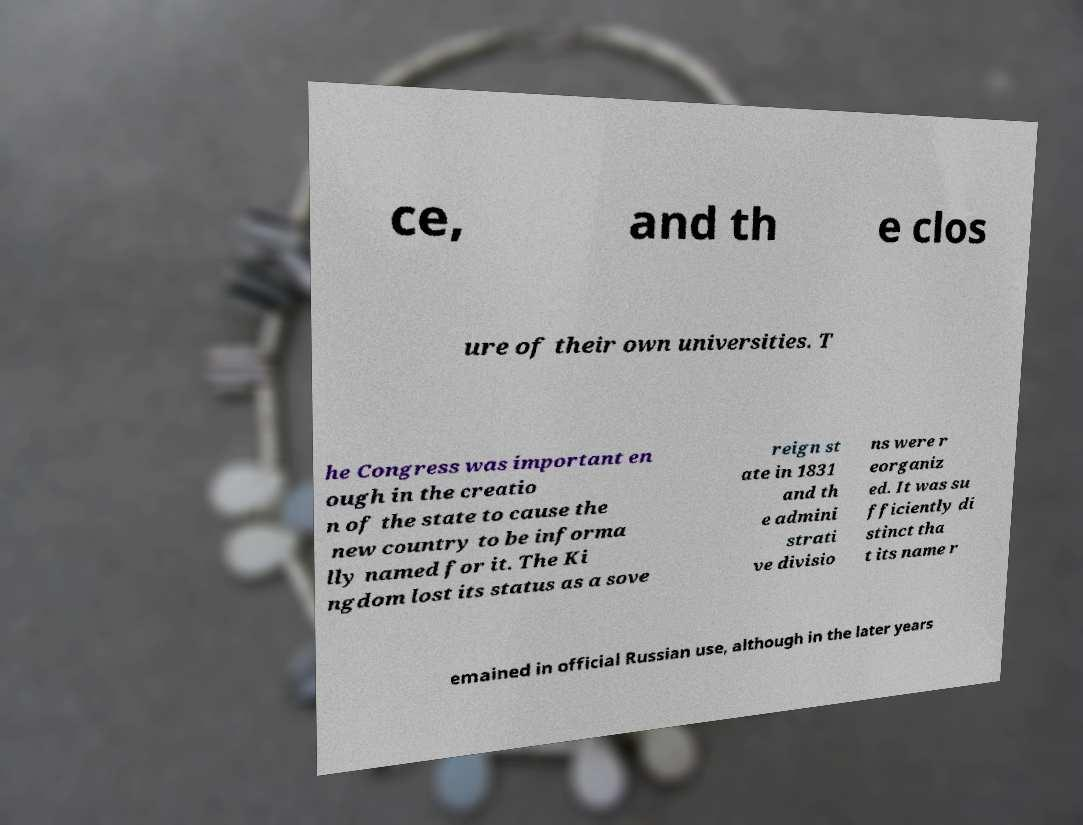Could you assist in decoding the text presented in this image and type it out clearly? ce, and th e clos ure of their own universities. T he Congress was important en ough in the creatio n of the state to cause the new country to be informa lly named for it. The Ki ngdom lost its status as a sove reign st ate in 1831 and th e admini strati ve divisio ns were r eorganiz ed. It was su fficiently di stinct tha t its name r emained in official Russian use, although in the later years 